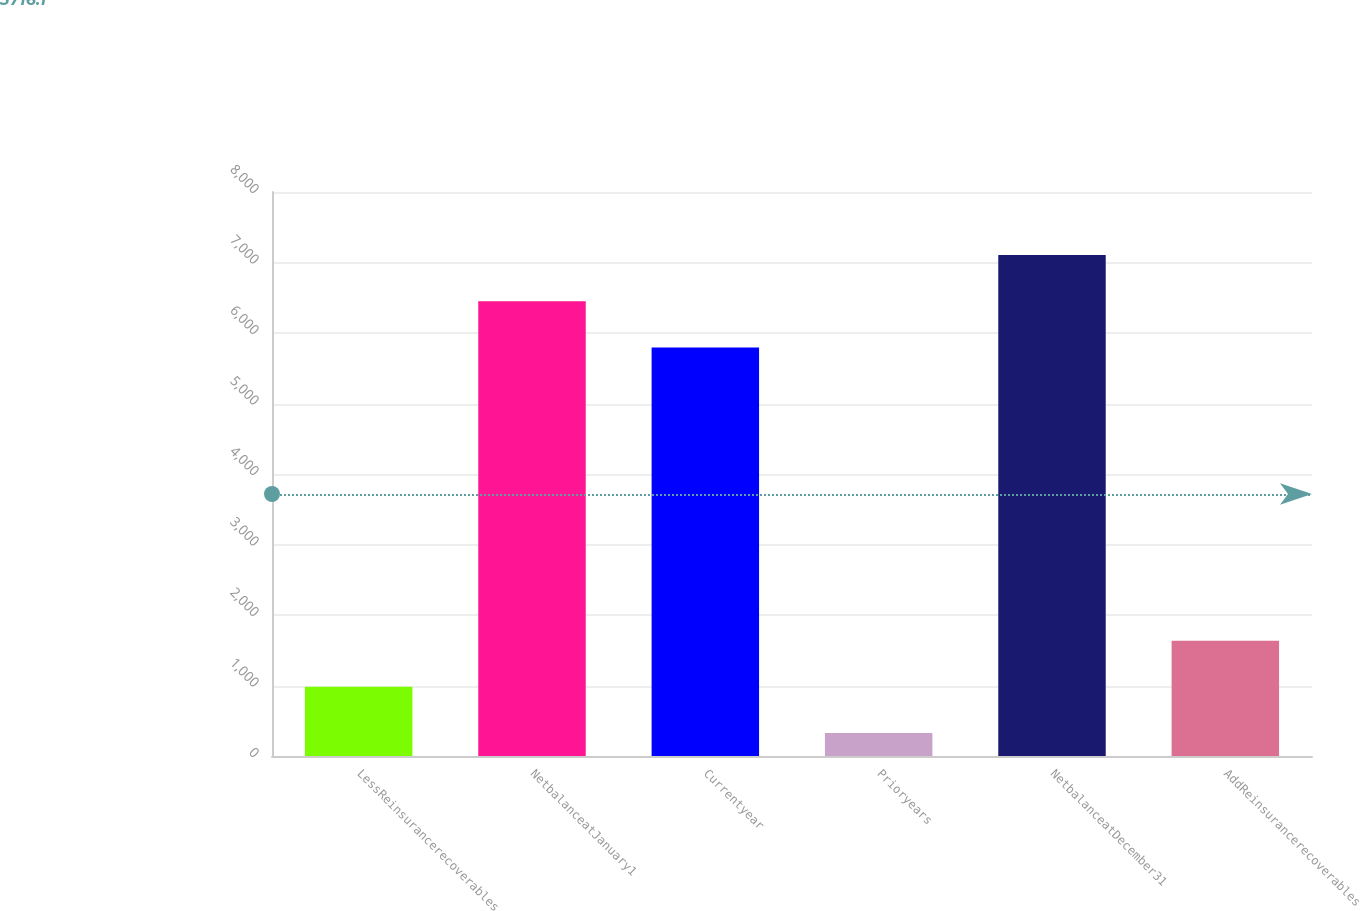<chart> <loc_0><loc_0><loc_500><loc_500><bar_chart><fcel>LessReinsurancerecoverables<fcel>NetbalanceatJanuary1<fcel>Currentyear<fcel>Prioryears<fcel>NetbalanceatDecember31<fcel>AddReinsurancerecoverables<nl><fcel>980.6<fcel>6451.6<fcel>5796<fcel>325<fcel>7107.2<fcel>1636.2<nl></chart> 